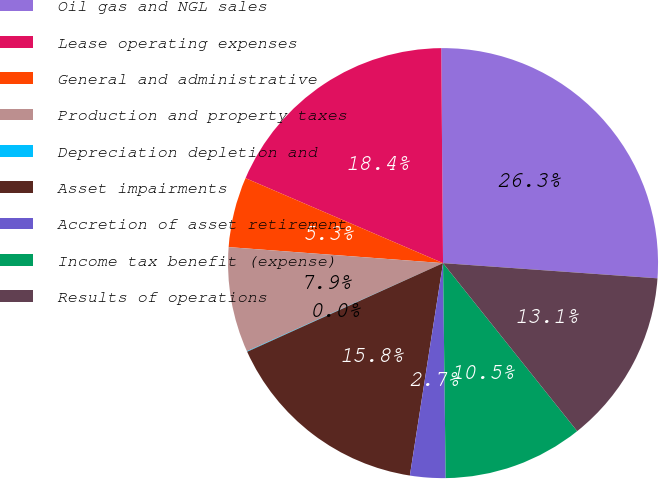<chart> <loc_0><loc_0><loc_500><loc_500><pie_chart><fcel>Oil gas and NGL sales<fcel>Lease operating expenses<fcel>General and administrative<fcel>Production and property taxes<fcel>Depreciation depletion and<fcel>Asset impairments<fcel>Accretion of asset retirement<fcel>Income tax benefit (expense)<fcel>Results of operations<nl><fcel>26.26%<fcel>18.4%<fcel>5.28%<fcel>7.91%<fcel>0.04%<fcel>15.77%<fcel>2.66%<fcel>10.53%<fcel>13.15%<nl></chart> 